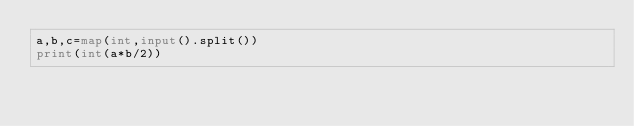Convert code to text. <code><loc_0><loc_0><loc_500><loc_500><_Python_>a,b,c=map(int,input().split())
print(int(a*b/2))</code> 